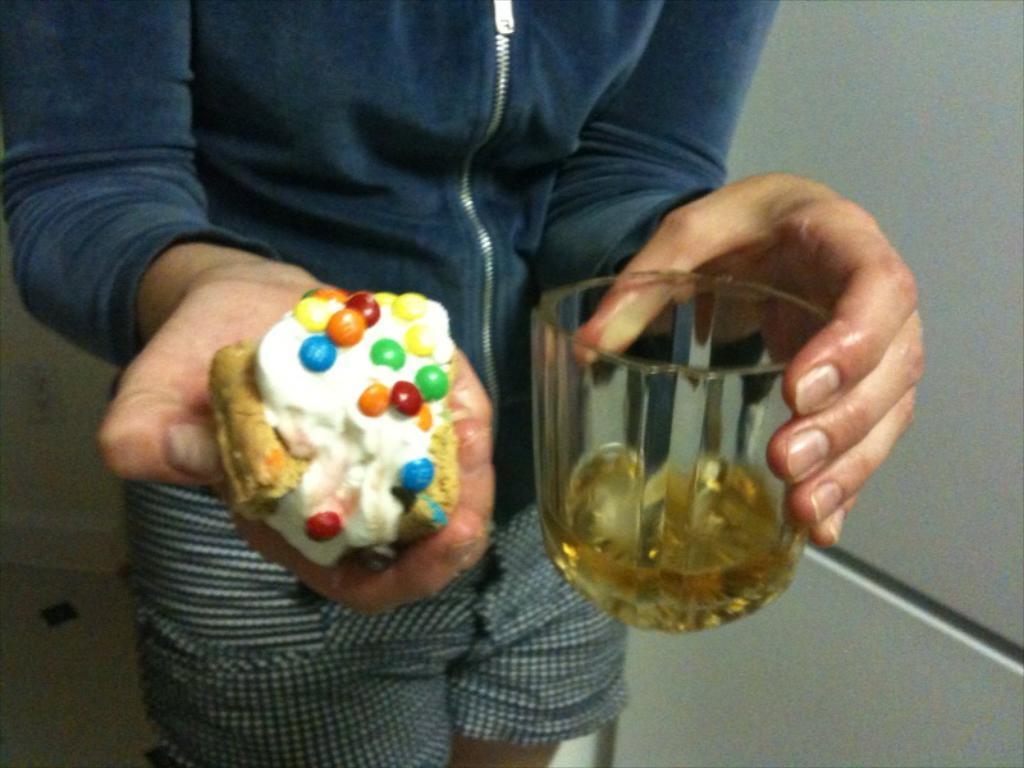Could you give a brief overview of what you see in this image? In this image, in the middle, we can see a man wearing a blue color jacket holding a wine glass in one hand and food item on the other hand. On the right side, we can see a white color wall. 